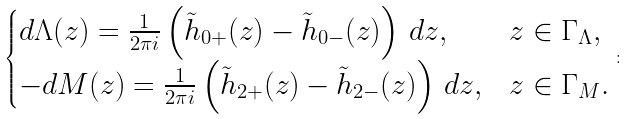Convert formula to latex. <formula><loc_0><loc_0><loc_500><loc_500>\begin{cases} d \Lambda ( z ) = \frac { 1 } { 2 \pi i } \left ( \tilde { h } _ { 0 + } ( z ) - \tilde { h } _ { 0 - } ( z ) \right ) \, d z , & z \in \Gamma _ { \Lambda } , \\ - d M ( z ) = \frac { 1 } { 2 \pi i } \left ( \tilde { h } _ { 2 + } ( z ) - \tilde { h } _ { 2 - } ( z ) \right ) \, d z , & z \in \Gamma _ { M } . \end{cases} \colon</formula> 